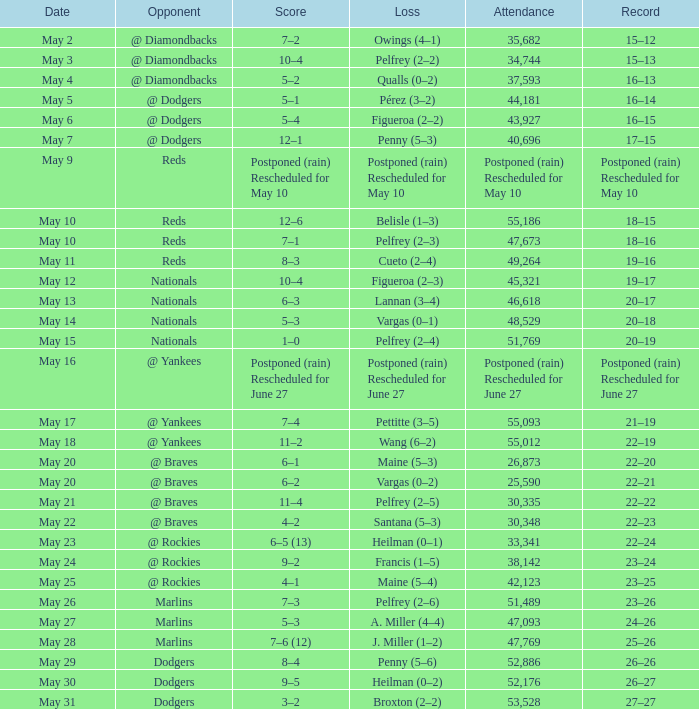Record of 22–20 involved what score? 6–1. 